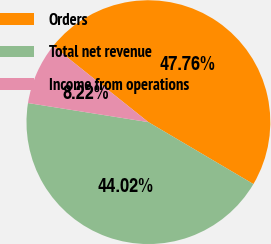<chart> <loc_0><loc_0><loc_500><loc_500><pie_chart><fcel>Orders<fcel>Total net revenue<fcel>Income from operations<nl><fcel>47.76%<fcel>44.02%<fcel>8.22%<nl></chart> 